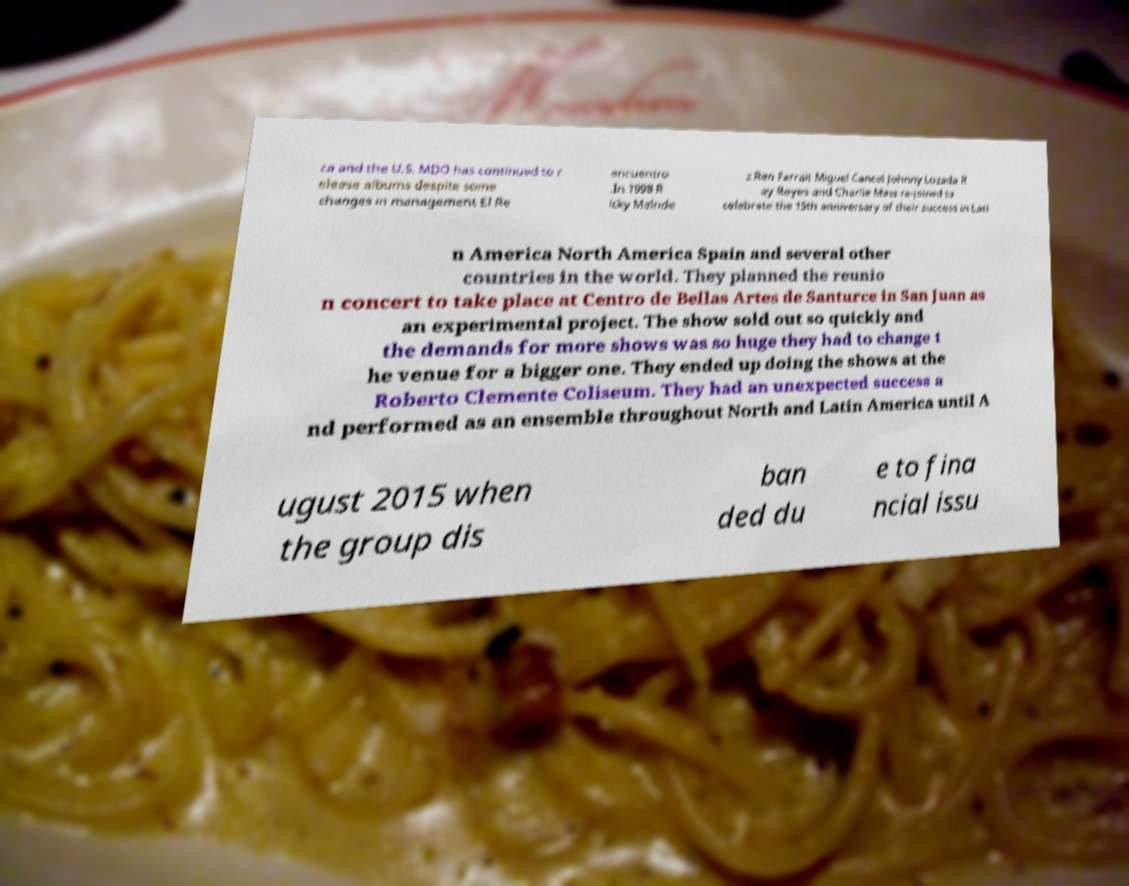Can you accurately transcribe the text from the provided image for me? ca and the U.S. MDO has continued to r elease albums despite some changes in management El Re encuentro .In 1998 R icky Melnde z Ren Farrait Miguel Cancel Johnny Lozada R ay Reyes and Charlie Mass re-joined to celebrate the 15th anniversary of their success in Lati n America North America Spain and several other countries in the world. They planned the reunio n concert to take place at Centro de Bellas Artes de Santurce in San Juan as an experimental project. The show sold out so quickly and the demands for more shows was so huge they had to change t he venue for a bigger one. They ended up doing the shows at the Roberto Clemente Coliseum. They had an unexpected success a nd performed as an ensemble throughout North and Latin America until A ugust 2015 when the group dis ban ded du e to fina ncial issu 